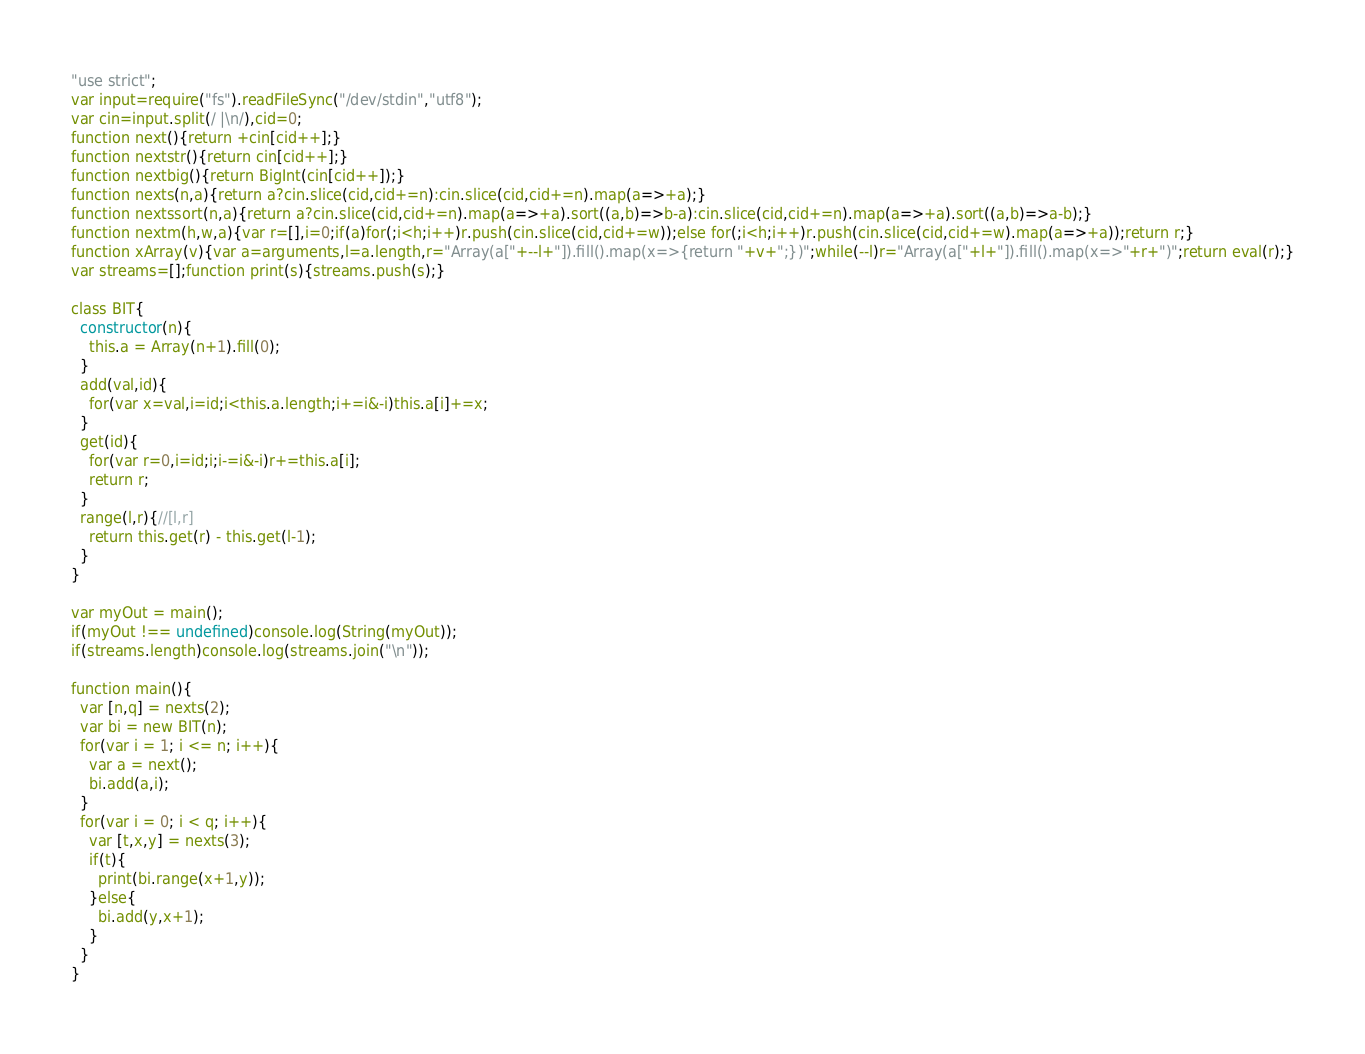Convert code to text. <code><loc_0><loc_0><loc_500><loc_500><_JavaScript_>"use strict";
var input=require("fs").readFileSync("/dev/stdin","utf8");
var cin=input.split(/ |\n/),cid=0;
function next(){return +cin[cid++];}
function nextstr(){return cin[cid++];}
function nextbig(){return BigInt(cin[cid++]);}
function nexts(n,a){return a?cin.slice(cid,cid+=n):cin.slice(cid,cid+=n).map(a=>+a);}
function nextssort(n,a){return a?cin.slice(cid,cid+=n).map(a=>+a).sort((a,b)=>b-a):cin.slice(cid,cid+=n).map(a=>+a).sort((a,b)=>a-b);}
function nextm(h,w,a){var r=[],i=0;if(a)for(;i<h;i++)r.push(cin.slice(cid,cid+=w));else for(;i<h;i++)r.push(cin.slice(cid,cid+=w).map(a=>+a));return r;}
function xArray(v){var a=arguments,l=a.length,r="Array(a["+--l+"]).fill().map(x=>{return "+v+";})";while(--l)r="Array(a["+l+"]).fill().map(x=>"+r+")";return eval(r);}
var streams=[];function print(s){streams.push(s);}

class BIT{
  constructor(n){
    this.a = Array(n+1).fill(0);
  }
  add(val,id){
    for(var x=val,i=id;i<this.a.length;i+=i&-i)this.a[i]+=x;
  }
  get(id){
    for(var r=0,i=id;i;i-=i&-i)r+=this.a[i];
    return r;
  }
  range(l,r){//[l,r]
    return this.get(r) - this.get(l-1);
  }
}

var myOut = main();
if(myOut !== undefined)console.log(String(myOut));
if(streams.length)console.log(streams.join("\n"));

function main(){
  var [n,q] = nexts(2);
  var bi = new BIT(n);
  for(var i = 1; i <= n; i++){
    var a = next();
    bi.add(a,i);
  }
  for(var i = 0; i < q; i++){
    var [t,x,y] = nexts(3);
    if(t){
      print(bi.range(x+1,y));
    }else{
      bi.add(y,x+1);
    }
  }
}</code> 